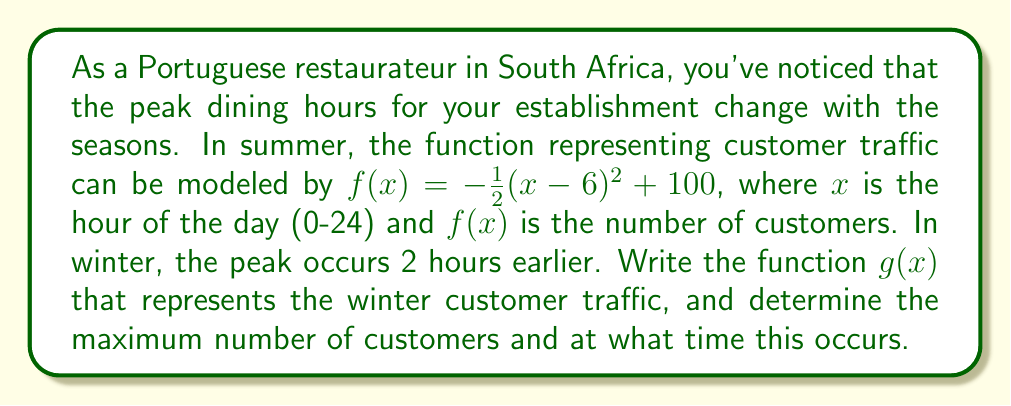Provide a solution to this math problem. To solve this problem, we need to follow these steps:

1. Identify the translation:
   The peak occurs 2 hours earlier in winter, which means we need to shift the function 2 units to the left on the x-axis.

2. Transform the function:
   To shift a function 2 units left, we replace every $x$ with $(x+2)$:
   $g(x) = -\frac{1}{2}((x+2)-6)^2 + 100$
   $g(x) = -\frac{1}{2}(x-4)^2 + 100$

3. Find the maximum:
   The maximum occurs at the vertex of the parabola. For a function in the form $f(x) = -a(x-h)^2 + k$, the vertex is at $(h,k)$.

   In our case, $g(x) = -\frac{1}{2}(x-4)^2 + 100$, so the vertex is at $(4,100)$.

4. Interpret the results:
   The maximum number of customers is 100, occurring at x = 4, which represents 4:00 PM in 24-hour time.
Answer: The winter customer traffic function is $g(x) = -\frac{1}{2}(x-4)^2 + 100$. The maximum number of customers is 100, occurring at 4:00 PM. 